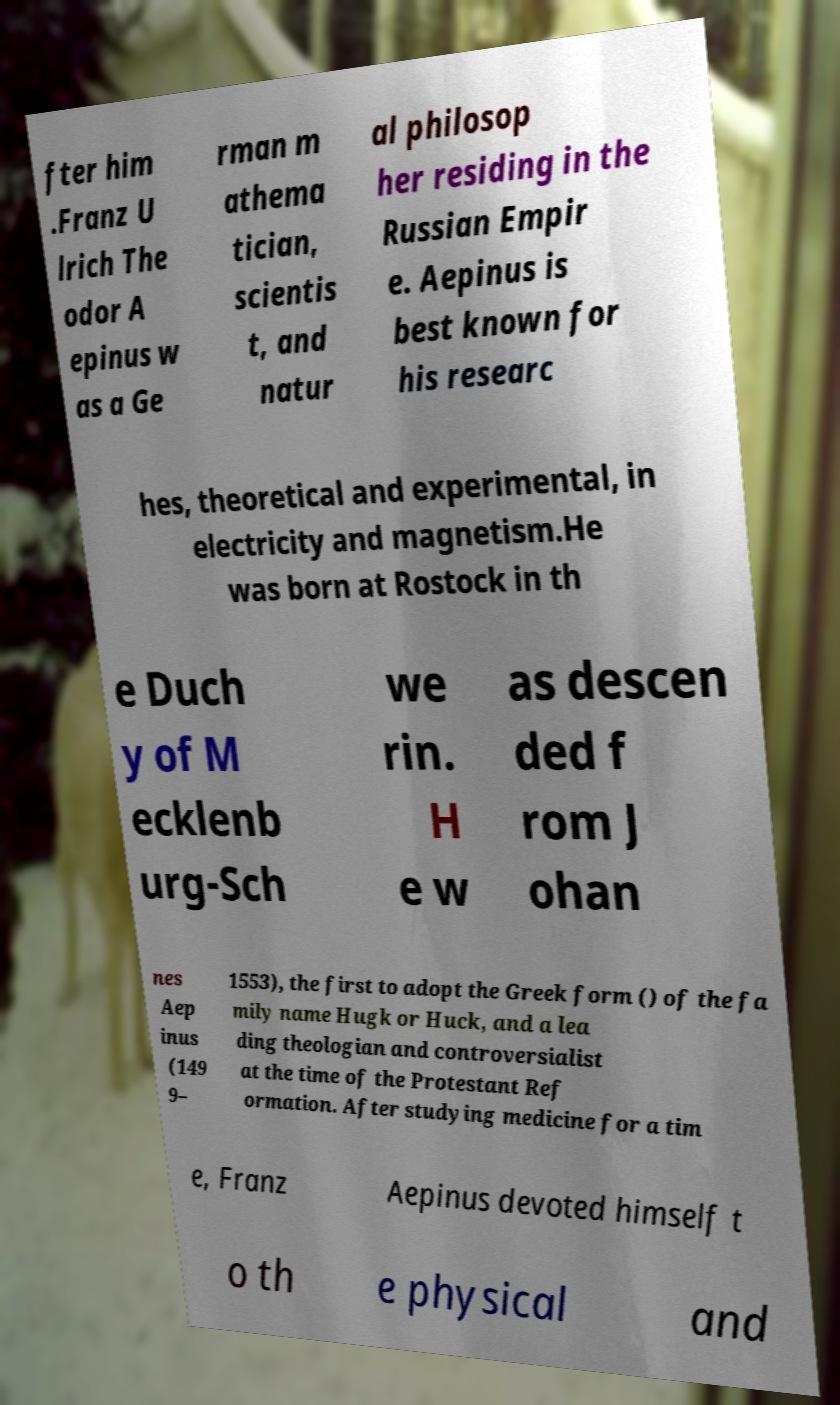Could you assist in decoding the text presented in this image and type it out clearly? fter him .Franz U lrich The odor A epinus w as a Ge rman m athema tician, scientis t, and natur al philosop her residing in the Russian Empir e. Aepinus is best known for his researc hes, theoretical and experimental, in electricity and magnetism.He was born at Rostock in th e Duch y of M ecklenb urg-Sch we rin. H e w as descen ded f rom J ohan nes Aep inus (149 9– 1553), the first to adopt the Greek form () of the fa mily name Hugk or Huck, and a lea ding theologian and controversialist at the time of the Protestant Ref ormation. After studying medicine for a tim e, Franz Aepinus devoted himself t o th e physical and 